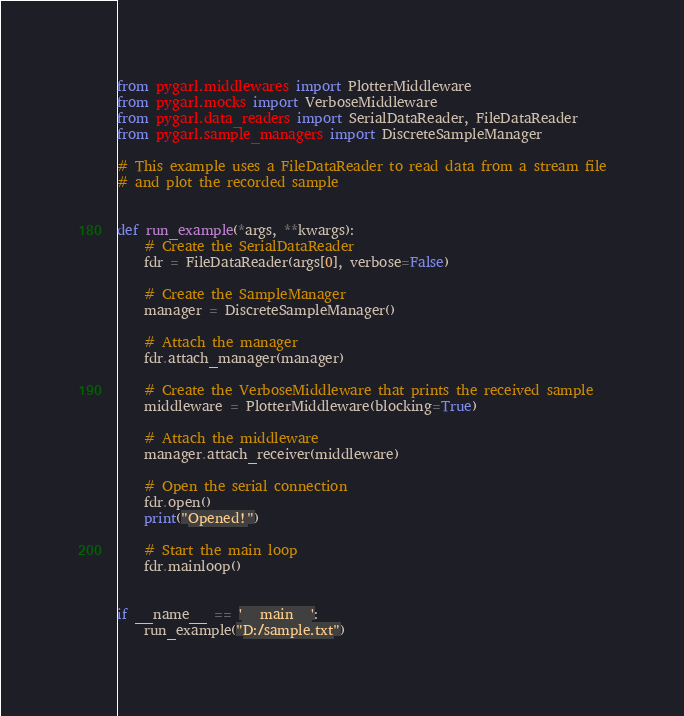<code> <loc_0><loc_0><loc_500><loc_500><_Python_>from pygarl.middlewares import PlotterMiddleware
from pygarl.mocks import VerboseMiddleware
from pygarl.data_readers import SerialDataReader, FileDataReader
from pygarl.sample_managers import DiscreteSampleManager

# This example uses a FileDataReader to read data from a stream file
# and plot the recorded sample


def run_example(*args, **kwargs):
    # Create the SerialDataReader
    fdr = FileDataReader(args[0], verbose=False)

    # Create the SampleManager
    manager = DiscreteSampleManager()

    # Attach the manager
    fdr.attach_manager(manager)

    # Create the VerboseMiddleware that prints the received sample
    middleware = PlotterMiddleware(blocking=True)

    # Attach the middleware
    manager.attach_receiver(middleware)

    # Open the serial connection
    fdr.open()
    print("Opened!")

    # Start the main loop
    fdr.mainloop()


if __name__ == '__main__':
    run_example("D:/sample.txt")
</code> 